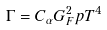Convert formula to latex. <formula><loc_0><loc_0><loc_500><loc_500>\Gamma = C _ { \alpha } G _ { F } ^ { 2 } p T ^ { 4 }</formula> 